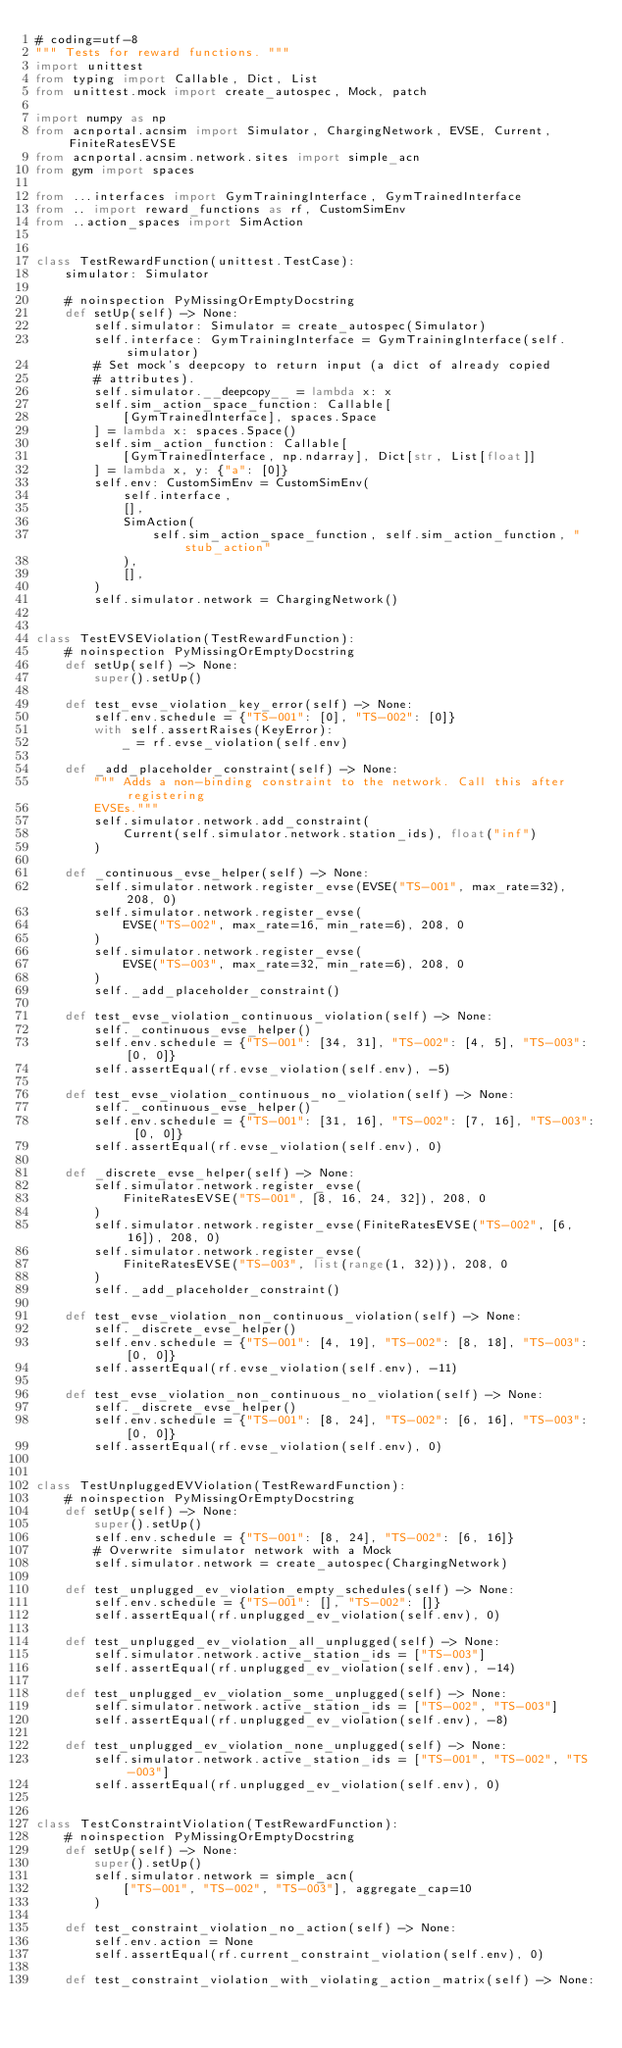Convert code to text. <code><loc_0><loc_0><loc_500><loc_500><_Python_># coding=utf-8
""" Tests for reward functions. """
import unittest
from typing import Callable, Dict, List
from unittest.mock import create_autospec, Mock, patch

import numpy as np
from acnportal.acnsim import Simulator, ChargingNetwork, EVSE, Current, FiniteRatesEVSE
from acnportal.acnsim.network.sites import simple_acn
from gym import spaces

from ...interfaces import GymTrainingInterface, GymTrainedInterface
from .. import reward_functions as rf, CustomSimEnv
from ..action_spaces import SimAction


class TestRewardFunction(unittest.TestCase):
    simulator: Simulator

    # noinspection PyMissingOrEmptyDocstring
    def setUp(self) -> None:
        self.simulator: Simulator = create_autospec(Simulator)
        self.interface: GymTrainingInterface = GymTrainingInterface(self.simulator)
        # Set mock's deepcopy to return input (a dict of already copied
        # attributes).
        self.simulator.__deepcopy__ = lambda x: x
        self.sim_action_space_function: Callable[
            [GymTrainedInterface], spaces.Space
        ] = lambda x: spaces.Space()
        self.sim_action_function: Callable[
            [GymTrainedInterface, np.ndarray], Dict[str, List[float]]
        ] = lambda x, y: {"a": [0]}
        self.env: CustomSimEnv = CustomSimEnv(
            self.interface,
            [],
            SimAction(
                self.sim_action_space_function, self.sim_action_function, "stub_action"
            ),
            [],
        )
        self.simulator.network = ChargingNetwork()


class TestEVSEViolation(TestRewardFunction):
    # noinspection PyMissingOrEmptyDocstring
    def setUp(self) -> None:
        super().setUp()

    def test_evse_violation_key_error(self) -> None:
        self.env.schedule = {"TS-001": [0], "TS-002": [0]}
        with self.assertRaises(KeyError):
            _ = rf.evse_violation(self.env)

    def _add_placeholder_constraint(self) -> None:
        """ Adds a non-binding constraint to the network. Call this after registering
        EVSEs."""
        self.simulator.network.add_constraint(
            Current(self.simulator.network.station_ids), float("inf")
        )

    def _continuous_evse_helper(self) -> None:
        self.simulator.network.register_evse(EVSE("TS-001", max_rate=32), 208, 0)
        self.simulator.network.register_evse(
            EVSE("TS-002", max_rate=16, min_rate=6), 208, 0
        )
        self.simulator.network.register_evse(
            EVSE("TS-003", max_rate=32, min_rate=6), 208, 0
        )
        self._add_placeholder_constraint()

    def test_evse_violation_continuous_violation(self) -> None:
        self._continuous_evse_helper()
        self.env.schedule = {"TS-001": [34, 31], "TS-002": [4, 5], "TS-003": [0, 0]}
        self.assertEqual(rf.evse_violation(self.env), -5)

    def test_evse_violation_continuous_no_violation(self) -> None:
        self._continuous_evse_helper()
        self.env.schedule = {"TS-001": [31, 16], "TS-002": [7, 16], "TS-003": [0, 0]}
        self.assertEqual(rf.evse_violation(self.env), 0)

    def _discrete_evse_helper(self) -> None:
        self.simulator.network.register_evse(
            FiniteRatesEVSE("TS-001", [8, 16, 24, 32]), 208, 0
        )
        self.simulator.network.register_evse(FiniteRatesEVSE("TS-002", [6, 16]), 208, 0)
        self.simulator.network.register_evse(
            FiniteRatesEVSE("TS-003", list(range(1, 32))), 208, 0
        )
        self._add_placeholder_constraint()

    def test_evse_violation_non_continuous_violation(self) -> None:
        self._discrete_evse_helper()
        self.env.schedule = {"TS-001": [4, 19], "TS-002": [8, 18], "TS-003": [0, 0]}
        self.assertEqual(rf.evse_violation(self.env), -11)

    def test_evse_violation_non_continuous_no_violation(self) -> None:
        self._discrete_evse_helper()
        self.env.schedule = {"TS-001": [8, 24], "TS-002": [6, 16], "TS-003": [0, 0]}
        self.assertEqual(rf.evse_violation(self.env), 0)


class TestUnpluggedEVViolation(TestRewardFunction):
    # noinspection PyMissingOrEmptyDocstring
    def setUp(self) -> None:
        super().setUp()
        self.env.schedule = {"TS-001": [8, 24], "TS-002": [6, 16]}
        # Overwrite simulator network with a Mock
        self.simulator.network = create_autospec(ChargingNetwork)

    def test_unplugged_ev_violation_empty_schedules(self) -> None:
        self.env.schedule = {"TS-001": [], "TS-002": []}
        self.assertEqual(rf.unplugged_ev_violation(self.env), 0)

    def test_unplugged_ev_violation_all_unplugged(self) -> None:
        self.simulator.network.active_station_ids = ["TS-003"]
        self.assertEqual(rf.unplugged_ev_violation(self.env), -14)

    def test_unplugged_ev_violation_some_unplugged(self) -> None:
        self.simulator.network.active_station_ids = ["TS-002", "TS-003"]
        self.assertEqual(rf.unplugged_ev_violation(self.env), -8)

    def test_unplugged_ev_violation_none_unplugged(self) -> None:
        self.simulator.network.active_station_ids = ["TS-001", "TS-002", "TS-003"]
        self.assertEqual(rf.unplugged_ev_violation(self.env), 0)


class TestConstraintViolation(TestRewardFunction):
    # noinspection PyMissingOrEmptyDocstring
    def setUp(self) -> None:
        super().setUp()
        self.simulator.network = simple_acn(
            ["TS-001", "TS-002", "TS-003"], aggregate_cap=10
        )

    def test_constraint_violation_no_action(self) -> None:
        self.env.action = None
        self.assertEqual(rf.current_constraint_violation(self.env), 0)

    def test_constraint_violation_with_violating_action_matrix(self) -> None:</code> 